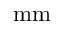<formula> <loc_0><loc_0><loc_500><loc_500>m m</formula> 